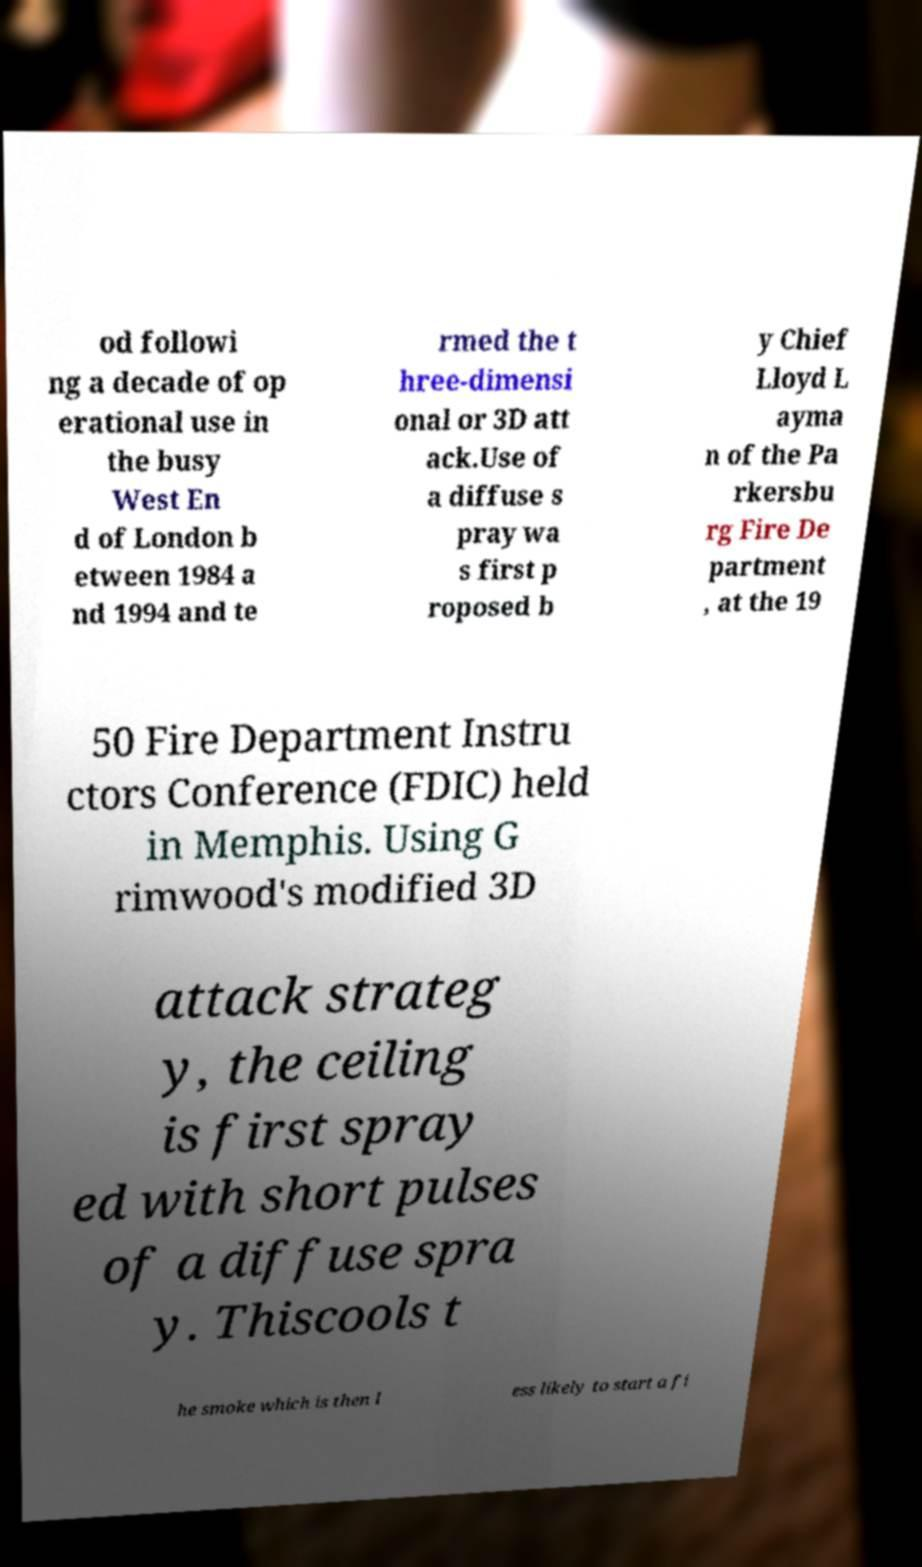Could you assist in decoding the text presented in this image and type it out clearly? od followi ng a decade of op erational use in the busy West En d of London b etween 1984 a nd 1994 and te rmed the t hree-dimensi onal or 3D att ack.Use of a diffuse s pray wa s first p roposed b y Chief Lloyd L ayma n of the Pa rkersbu rg Fire De partment , at the 19 50 Fire Department Instru ctors Conference (FDIC) held in Memphis. Using G rimwood's modified 3D attack strateg y, the ceiling is first spray ed with short pulses of a diffuse spra y. Thiscools t he smoke which is then l ess likely to start a fi 